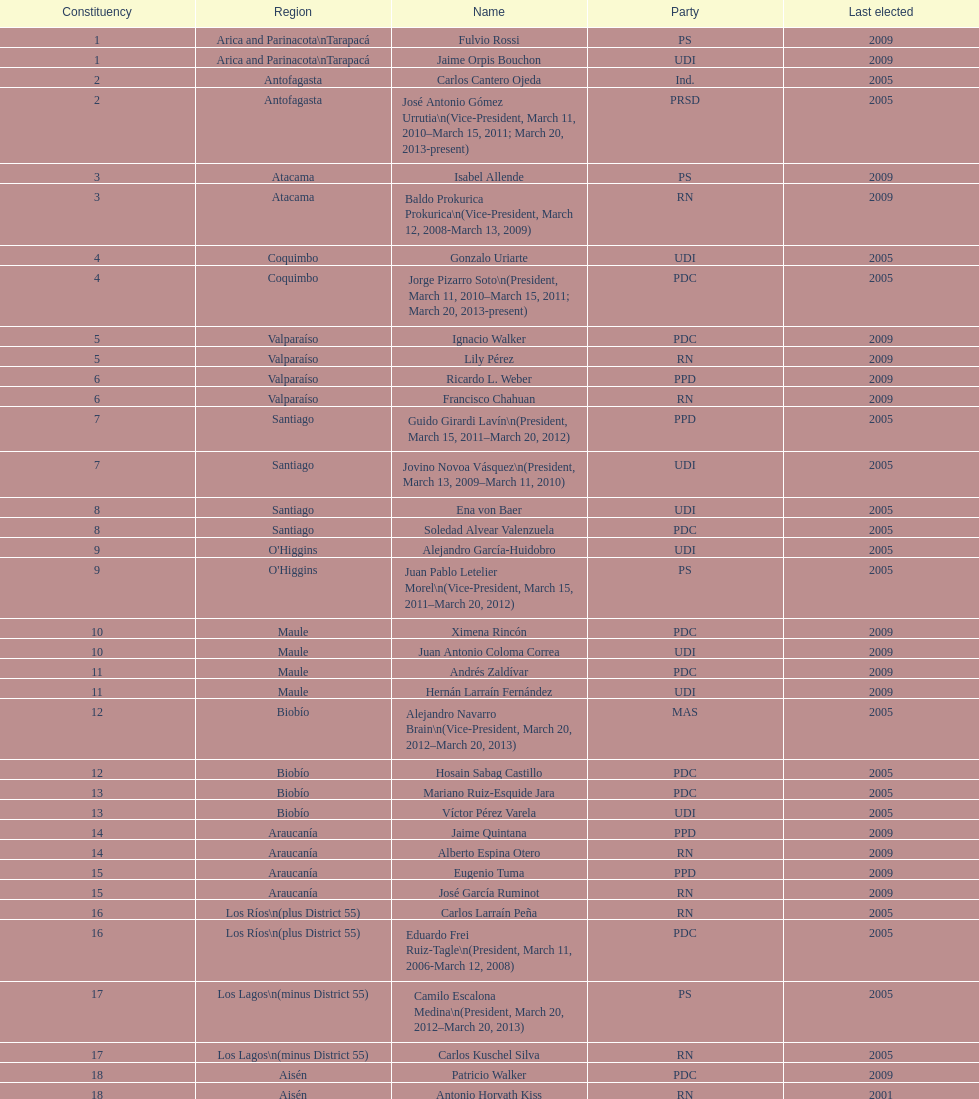Which political group was jaime quintana a member of? PPD. 